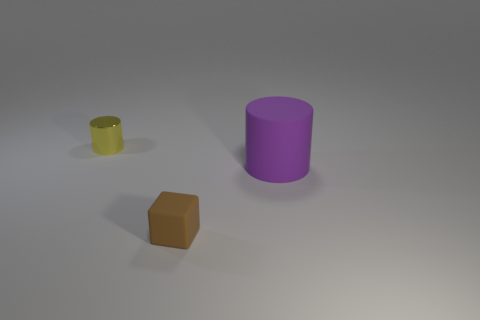Do the cylinder that is to the right of the yellow cylinder and the metallic thing have the same size?
Provide a succinct answer. No. Are the object that is on the left side of the brown cube and the cylinder in front of the yellow metal cylinder made of the same material?
Ensure brevity in your answer.  No. Is there another brown matte block that has the same size as the cube?
Keep it short and to the point. No. The thing behind the cylinder in front of the thing that is left of the tiny matte cube is what shape?
Give a very brief answer. Cylinder. Are there more tiny matte things in front of the tiny brown rubber block than brown things?
Make the answer very short. No. Is there a tiny shiny object of the same shape as the big thing?
Your response must be concise. Yes. Do the small cube and the cylinder right of the small rubber object have the same material?
Keep it short and to the point. Yes. What is the color of the tiny shiny cylinder?
Your answer should be compact. Yellow. How many metallic things are to the right of the object that is in front of the cylinder that is in front of the yellow object?
Ensure brevity in your answer.  0. There is a large purple thing; are there any brown objects left of it?
Offer a terse response. Yes. 